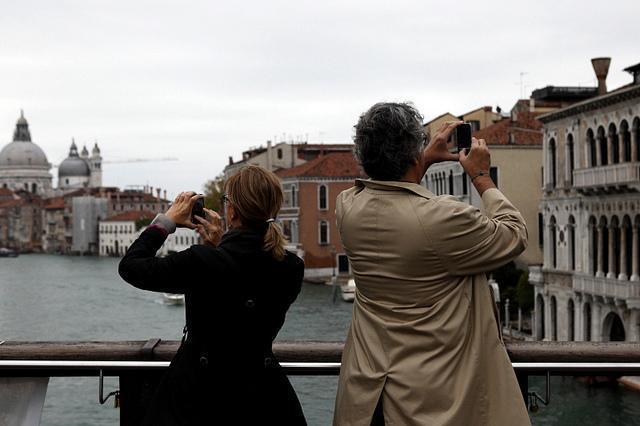How many people are in the photo?
Give a very brief answer. 2. 